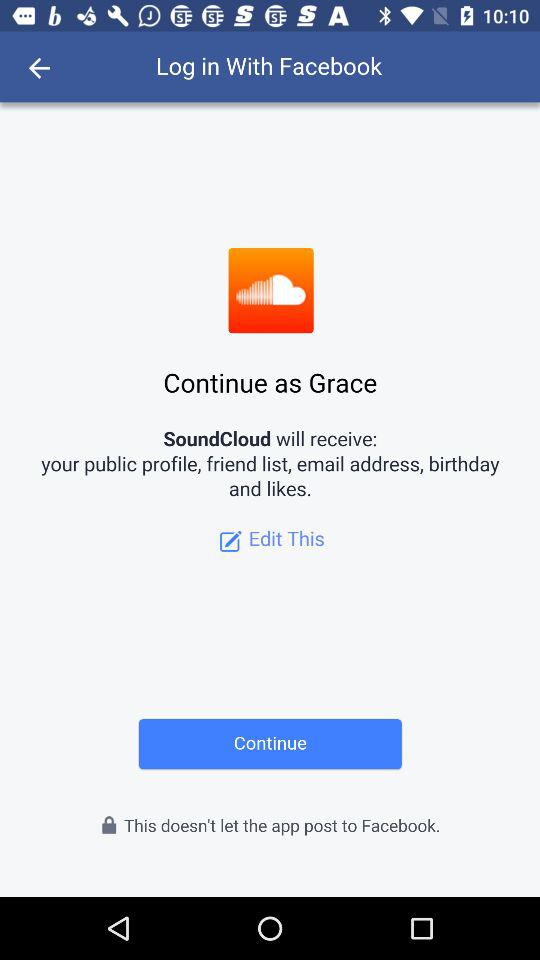What's the username? The username is Grace. 